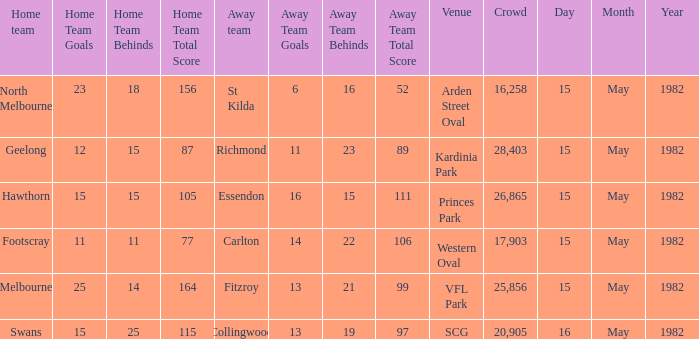What were the away team's points in the game with footscray? 14.22 (106). 